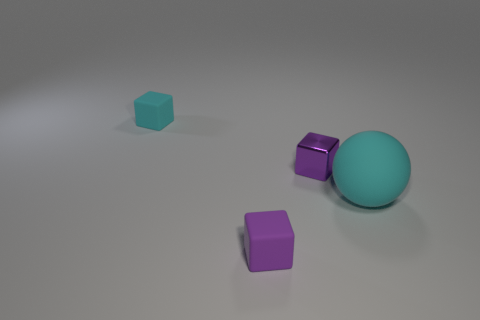Subtract all cyan rubber cubes. How many cubes are left? 2 Add 2 cyan matte spheres. How many objects exist? 6 Subtract 1 blocks. How many blocks are left? 2 Subtract all purple blocks. How many blocks are left? 1 Subtract all red balls. Subtract all cyan blocks. How many balls are left? 1 Subtract all blue spheres. How many blue cubes are left? 0 Subtract all purple metallic cubes. Subtract all purple metal cubes. How many objects are left? 2 Add 2 matte things. How many matte things are left? 5 Add 1 purple blocks. How many purple blocks exist? 3 Subtract 1 cyan cubes. How many objects are left? 3 